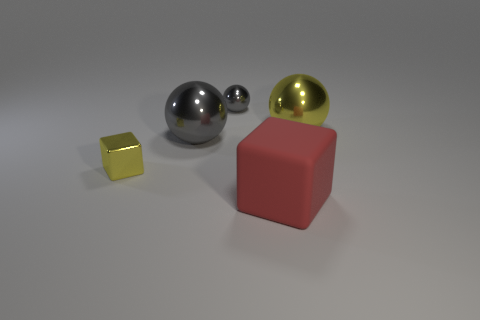Subtract all yellow balls. How many balls are left? 2 Subtract all yellow spheres. How many spheres are left? 2 Subtract all spheres. How many objects are left? 2 Subtract all yellow shiny blocks. Subtract all large gray metallic balls. How many objects are left? 3 Add 1 gray metal spheres. How many gray metal spheres are left? 3 Add 5 small gray metallic things. How many small gray metallic things exist? 6 Add 3 purple metallic spheres. How many objects exist? 8 Subtract 1 gray spheres. How many objects are left? 4 Subtract 2 balls. How many balls are left? 1 Subtract all green cubes. Subtract all red spheres. How many cubes are left? 2 